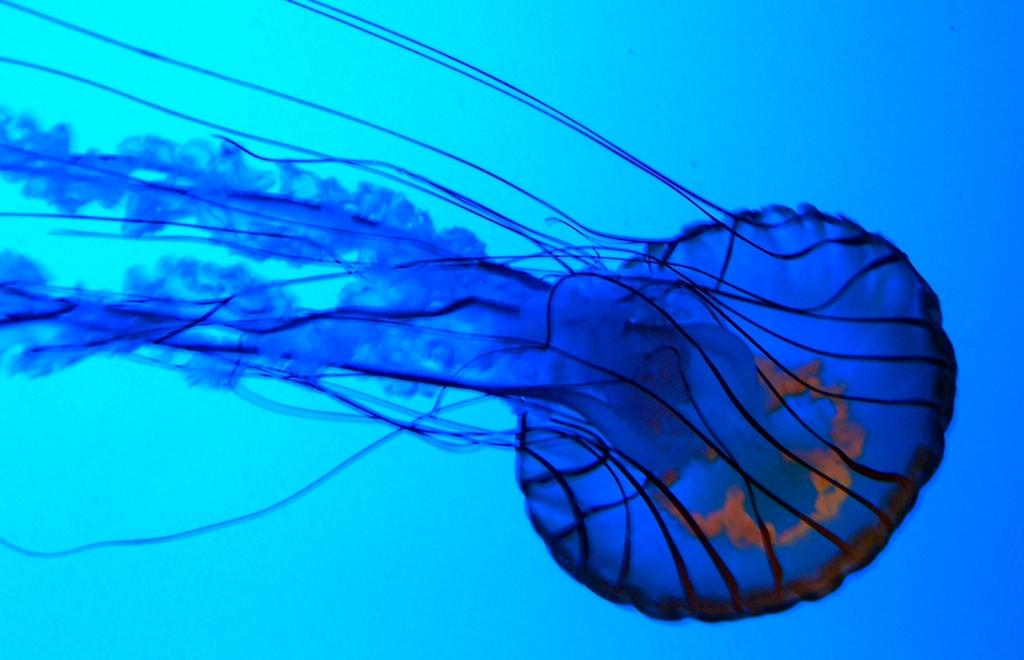What is the main subject of the image? There is a jellyfish in the image. What color is the background of the image? The background of the image is blue. How many yaks are present in the image? There are no yaks present in the image; it features a jellyfish in a blue background. 